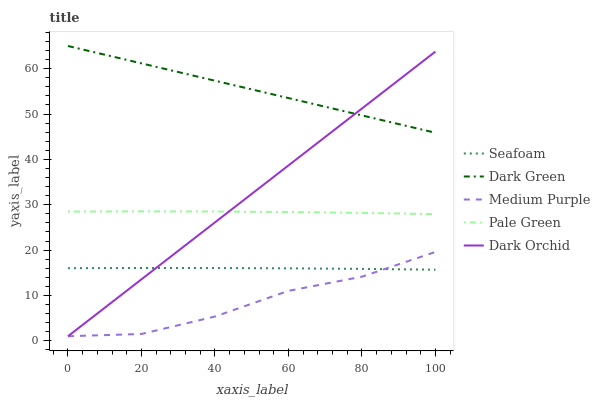Does Pale Green have the minimum area under the curve?
Answer yes or no. No. Does Pale Green have the maximum area under the curve?
Answer yes or no. No. Is Pale Green the smoothest?
Answer yes or no. No. Is Pale Green the roughest?
Answer yes or no. No. Does Pale Green have the lowest value?
Answer yes or no. No. Does Pale Green have the highest value?
Answer yes or no. No. Is Pale Green less than Dark Green?
Answer yes or no. Yes. Is Dark Green greater than Medium Purple?
Answer yes or no. Yes. Does Pale Green intersect Dark Green?
Answer yes or no. No. 